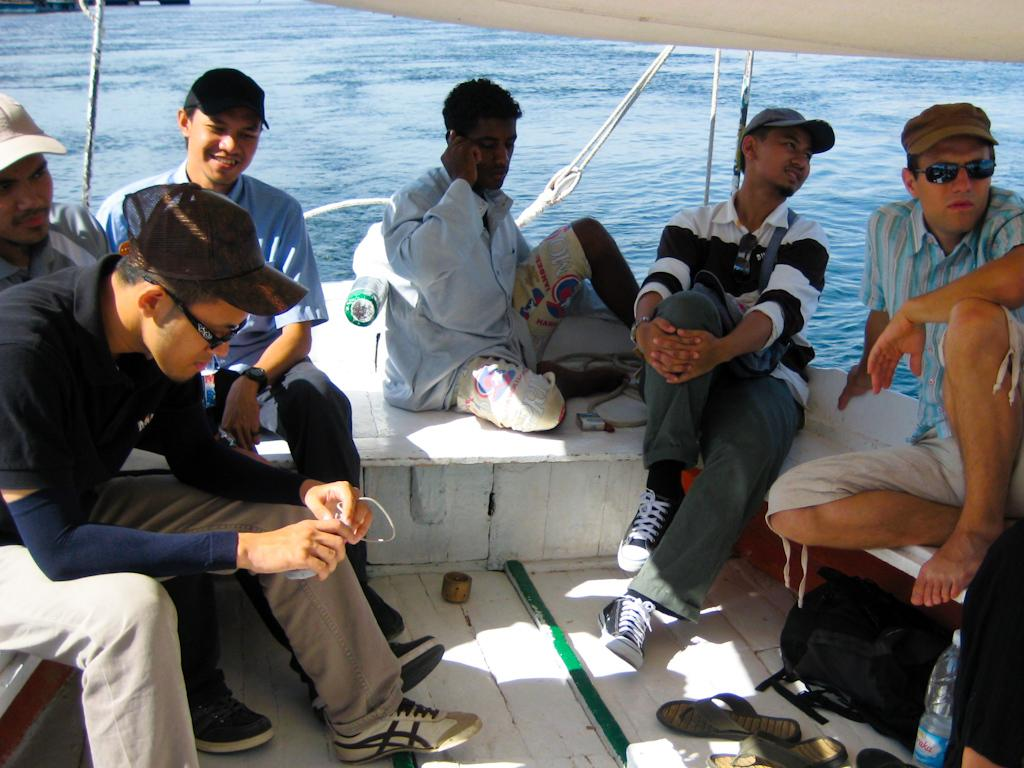How many people are in the image? There are six men in the image. What are the men doing in the image? The men are traveling in a boat. What can be seen in the background of the image? There is water visible in the background of the image. Can you touch the moon in the image? There is no moon present in the image, so it cannot be touched. What time of day is it in the image? The time of day cannot be determined from the image, as there are no specific clues or indicators present. 